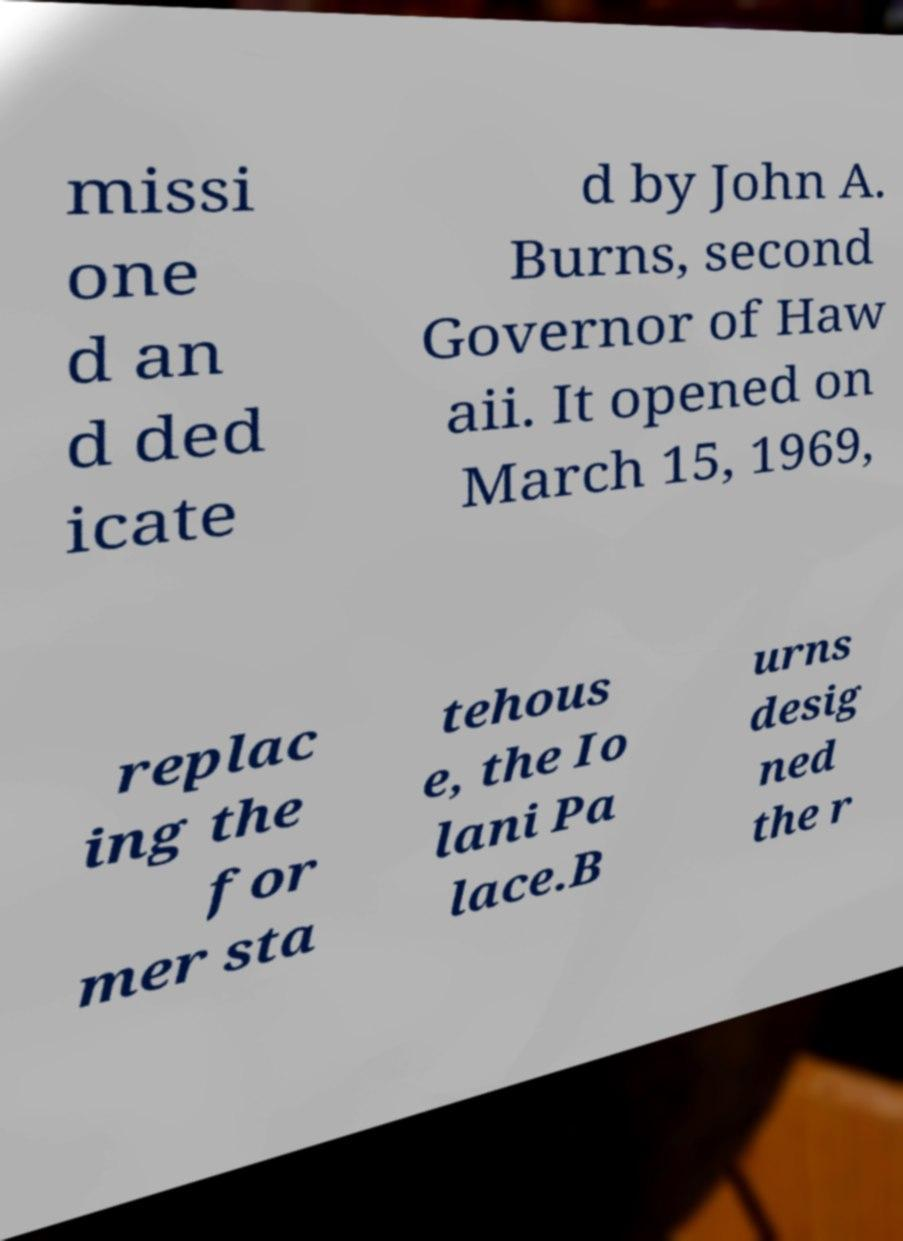Can you accurately transcribe the text from the provided image for me? missi one d an d ded icate d by John A. Burns, second Governor of Haw aii. It opened on March 15, 1969, replac ing the for mer sta tehous e, the Io lani Pa lace.B urns desig ned the r 